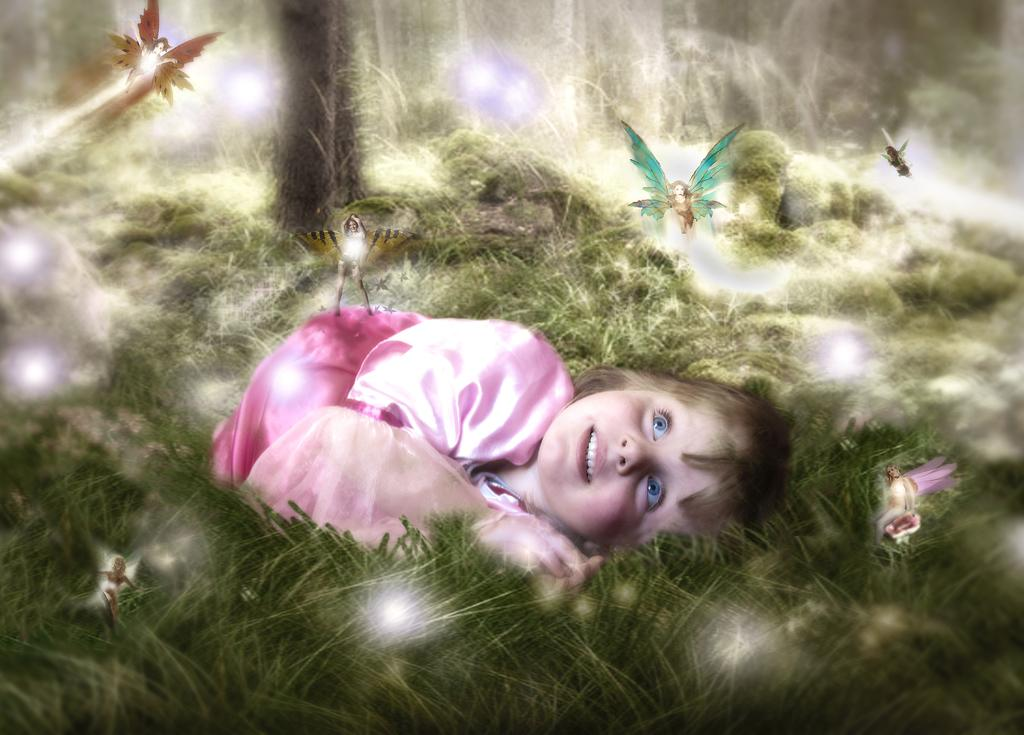Who is the main subject in the image? There is a small girl in the image. What is the girl doing in the image? The girl is sleeping on the grass. What can be seen in the sky in the image? There are flying objects in the image that resemble angels. What country is the girl from in the image? The provided facts do not mention the girl's country of origin, so we cannot determine her country from the image. 